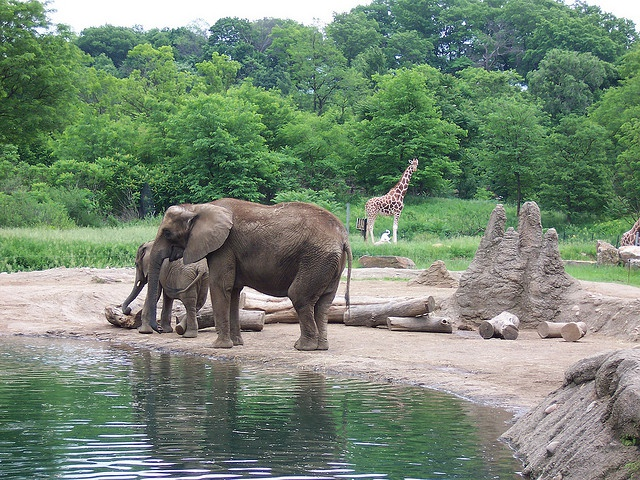Describe the objects in this image and their specific colors. I can see elephant in green, gray, black, and darkgray tones, elephant in green, gray, black, and darkgray tones, and giraffe in green, lightgray, darkgray, and gray tones in this image. 